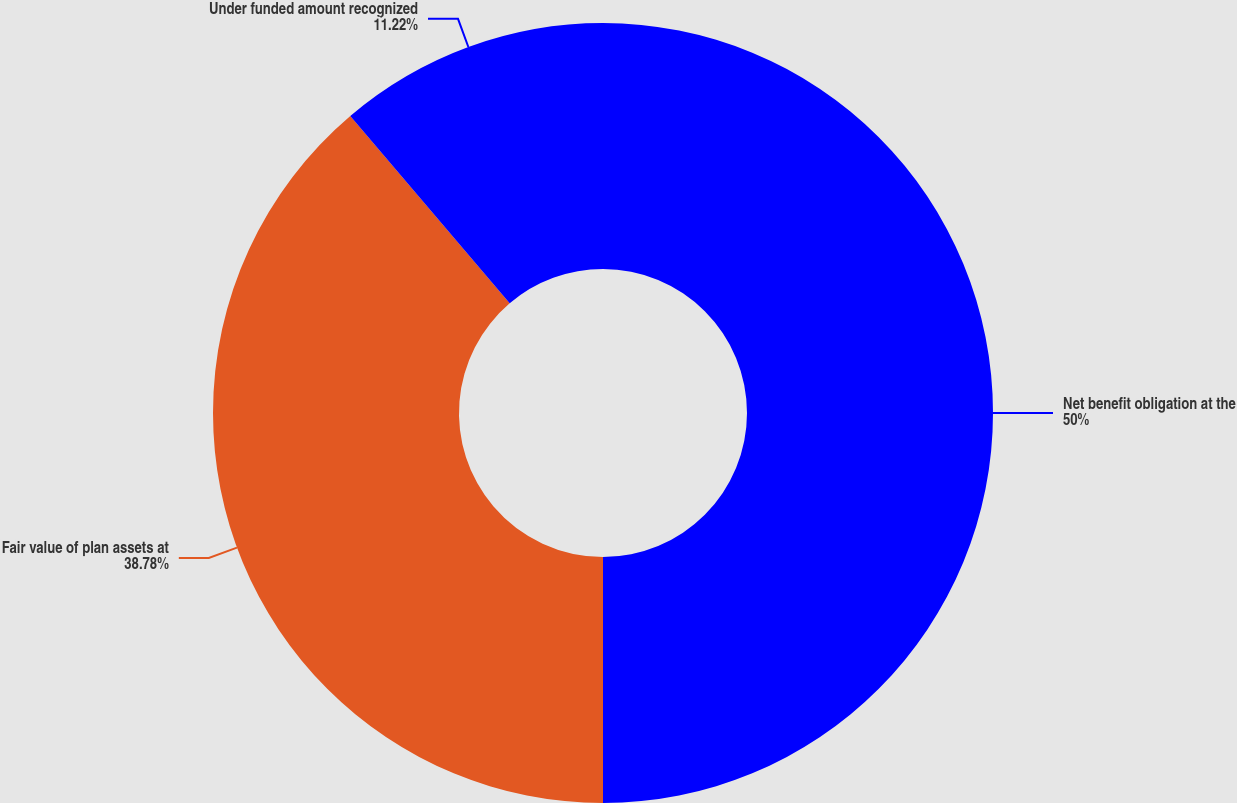Convert chart. <chart><loc_0><loc_0><loc_500><loc_500><pie_chart><fcel>Net benefit obligation at the<fcel>Fair value of plan assets at<fcel>Under funded amount recognized<nl><fcel>50.0%<fcel>38.78%<fcel>11.22%<nl></chart> 